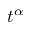<formula> <loc_0><loc_0><loc_500><loc_500>t ^ { \alpha }</formula> 